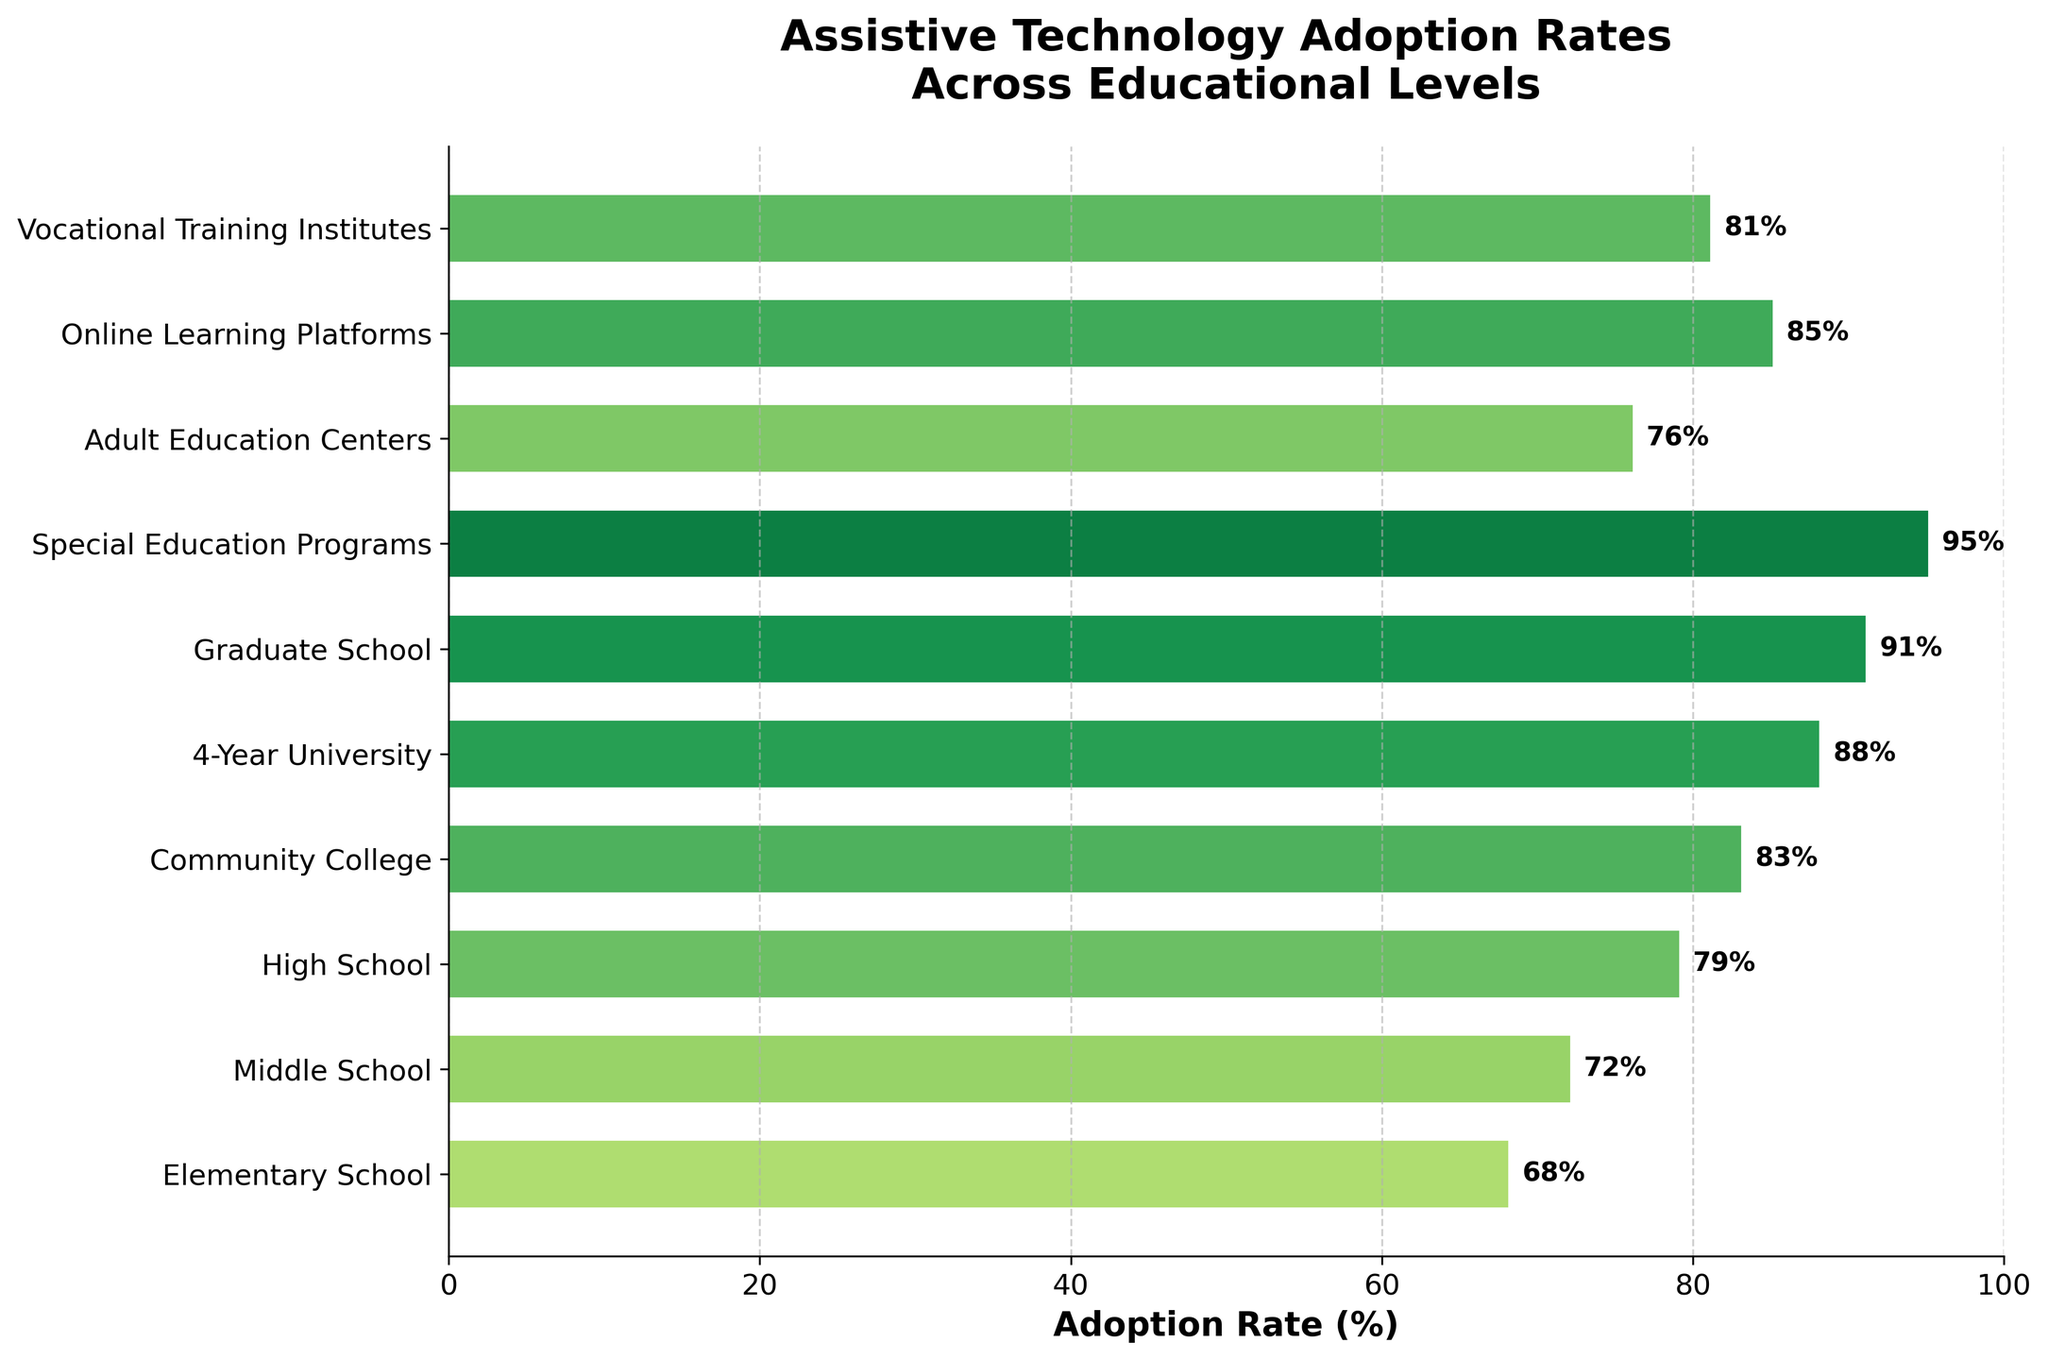Which educational level has the highest assistive technology adoption rate? The chart shows various educational levels and their corresponding assistive technology adoption rates. The bar with the highest value is for Special Education Programs, which has an adoption rate of 95%.
Answer: Special Education Programs What is the difference in adoption rates between Graduate School and Community College? The adoption rate for Graduate School is 91% and for Community College, it is 83%. Subtracting the latter from the former gives 91% - 83% = 8%.
Answer: 8% Which educational level has a lower adoption rate, Online Learning Platforms or Vocational Training Institutes? The bar representing Online Learning Platforms shows an adoption rate of 85%, while the bar for Vocational Training Institutes shows 81%. Since 81% < 85%, Vocational Training Institutes have a lower adoption rate.
Answer: Vocational Training Institutes What’s the average adoption rate across Elementary School, Middle School, and High School? The adoption rates are 68%, 72%, and 79% for Elementary School, Middle School, and High School, respectively. The average is calculated by summing these values and dividing by 3: (68 + 72 + 79) / 3 = 219 / 3 = 73%.
Answer: 73% What unique color pattern do bars with rates above 90% exhibit in the chart? The bars with adoption rates above 90% represent Graduate School and Special Education Programs. These bars are colored green, as indicated by the color gradient used in the chart.
Answer: Green Which two educational levels have exactly a 2% difference in their adoption rates and what are their rates? By visually comparing the bar lengths, Community College has an adoption rate of 83%, and Vocational Training Institutes have 81%. The difference is 83% - 81% = 2%.
Answer: Community College (83%), Vocational Training Institutes (81%) What is the total combined adoption rate for Special Education Programs, Adult Education Centers, and Online Learning Platforms? The adoption rates for these levels are 95%, 76%, and 85%, respectively. Adding these up: 95 + 76 + 85 = 256%.
Answer: 256% How many educational levels have an adoption rate above the mean adoption rate of all levels? First, calculate the mean adoption rate for all education levels: (68 + 72 + 79 + 83 + 88 + 91 + 95 + 76 + 85 + 81) / 10 = 818 / 10 = 81.8%. Educational levels with rates above 81.8% are High School (79%), Community College (83%), 4-Year University (88%), Graduate School (91%), Special Education Programs (95%), Online Learning Platforms (85%), and Vocational Training Institutes (81%), which makes 4 in total.
Answer: 4 